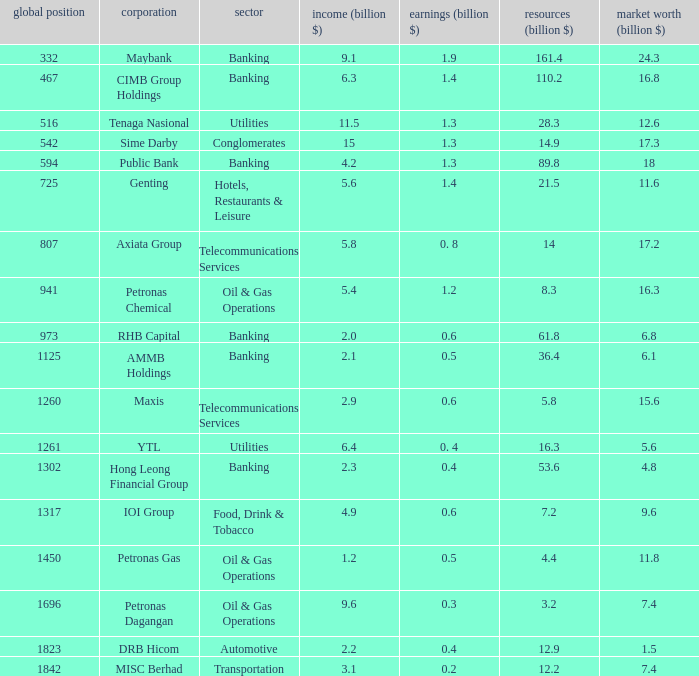Name the total number of industry for maxis 1.0. 